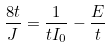Convert formula to latex. <formula><loc_0><loc_0><loc_500><loc_500>\frac { 8 t } { J } = \frac { 1 } { t I _ { 0 } } - \frac { E } { t }</formula> 